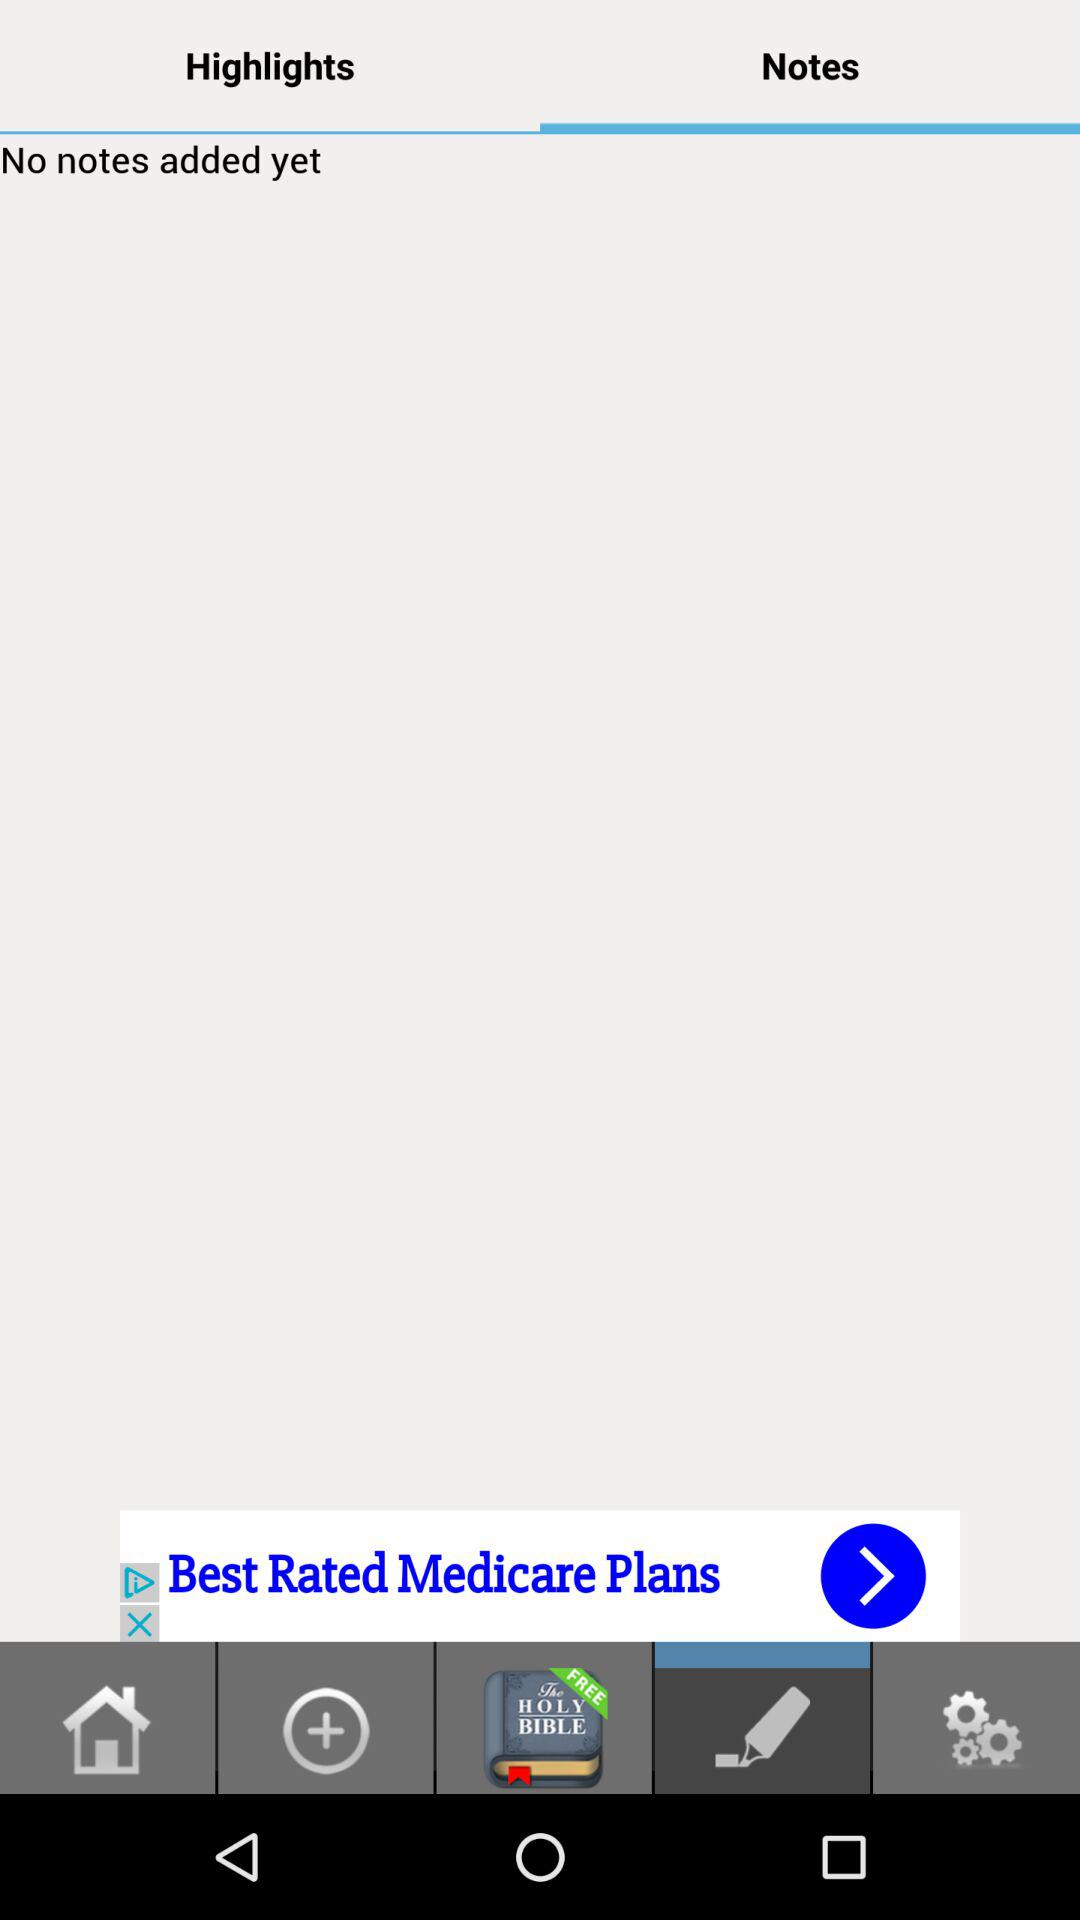How many notes are being added?
When the provided information is insufficient, respond with <no answer>. <no answer> 